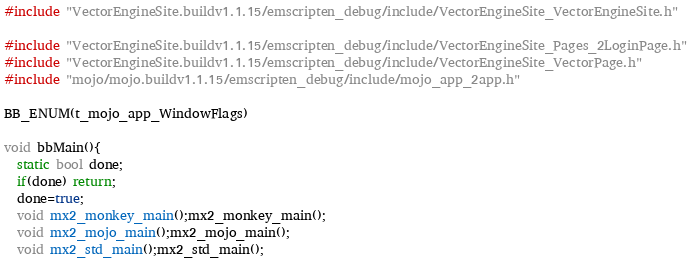Convert code to text. <code><loc_0><loc_0><loc_500><loc_500><_C++_>
#include "VectorEngineSite.buildv1.1.15/emscripten_debug/include/VectorEngineSite_VectorEngineSite.h"

#include "VectorEngineSite.buildv1.1.15/emscripten_debug/include/VectorEngineSite_Pages_2LoginPage.h"
#include "VectorEngineSite.buildv1.1.15/emscripten_debug/include/VectorEngineSite_VectorPage.h"
#include "mojo/mojo.buildv1.1.15/emscripten_debug/include/mojo_app_2app.h"

BB_ENUM(t_mojo_app_WindowFlags)

void bbMain(){
  static bool done;
  if(done) return;
  done=true;
  void mx2_monkey_main();mx2_monkey_main();
  void mx2_mojo_main();mx2_mojo_main();
  void mx2_std_main();mx2_std_main();</code> 